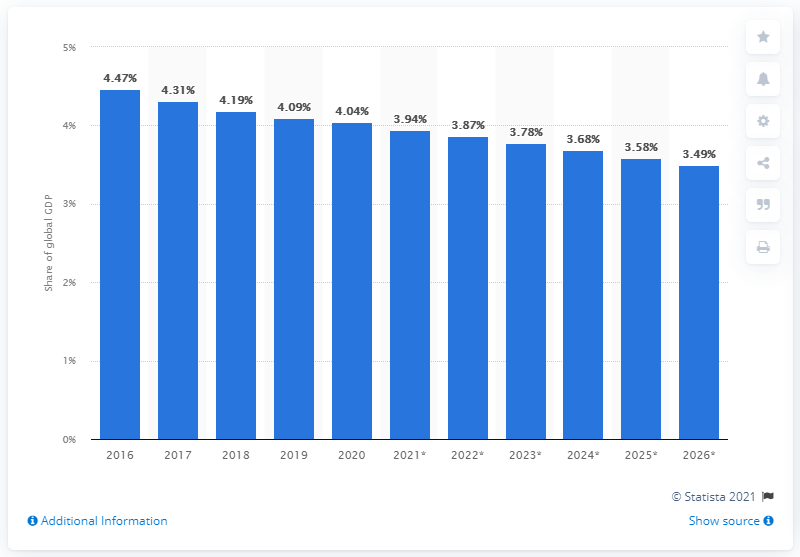Give some essential details in this illustration. In 2020, Japan's share of GDP was 4.04%. 